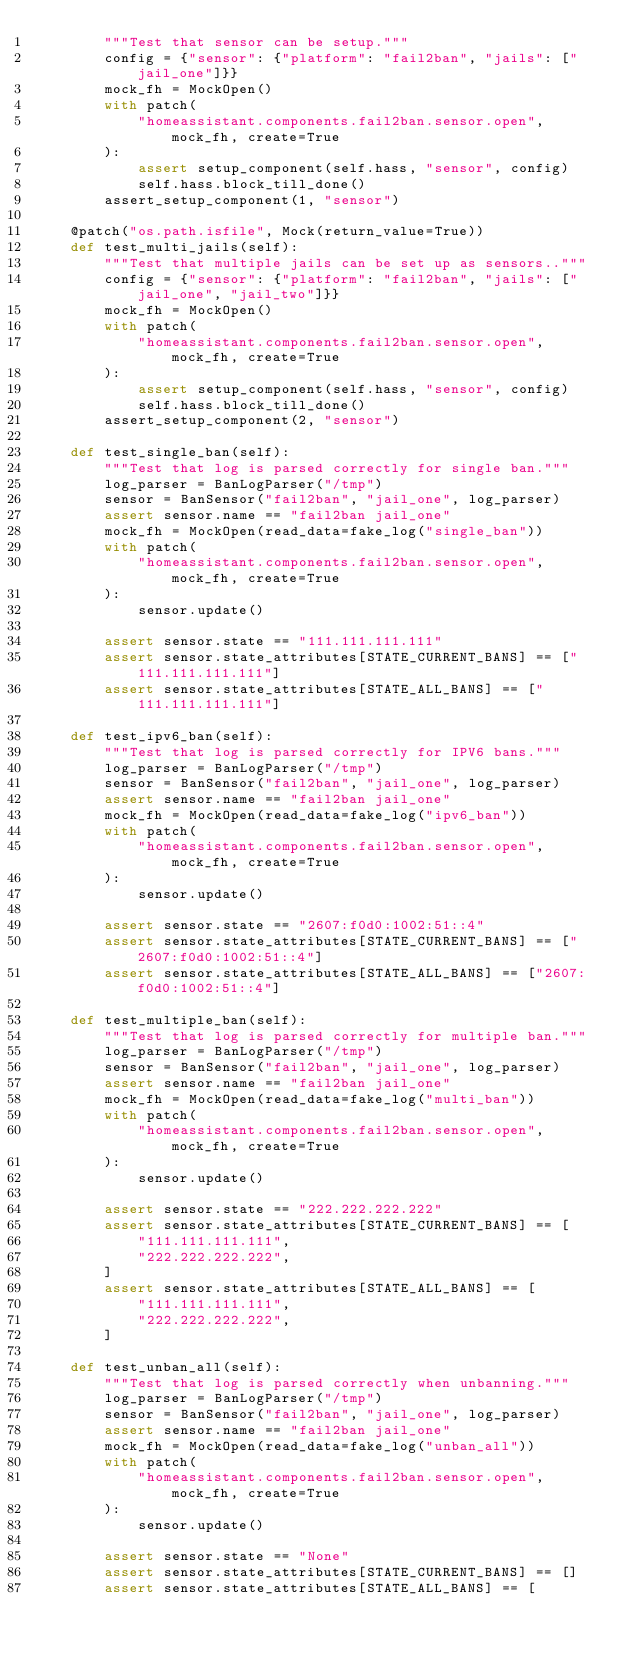Convert code to text. <code><loc_0><loc_0><loc_500><loc_500><_Python_>        """Test that sensor can be setup."""
        config = {"sensor": {"platform": "fail2ban", "jails": ["jail_one"]}}
        mock_fh = MockOpen()
        with patch(
            "homeassistant.components.fail2ban.sensor.open", mock_fh, create=True
        ):
            assert setup_component(self.hass, "sensor", config)
            self.hass.block_till_done()
        assert_setup_component(1, "sensor")

    @patch("os.path.isfile", Mock(return_value=True))
    def test_multi_jails(self):
        """Test that multiple jails can be set up as sensors.."""
        config = {"sensor": {"platform": "fail2ban", "jails": ["jail_one", "jail_two"]}}
        mock_fh = MockOpen()
        with patch(
            "homeassistant.components.fail2ban.sensor.open", mock_fh, create=True
        ):
            assert setup_component(self.hass, "sensor", config)
            self.hass.block_till_done()
        assert_setup_component(2, "sensor")

    def test_single_ban(self):
        """Test that log is parsed correctly for single ban."""
        log_parser = BanLogParser("/tmp")
        sensor = BanSensor("fail2ban", "jail_one", log_parser)
        assert sensor.name == "fail2ban jail_one"
        mock_fh = MockOpen(read_data=fake_log("single_ban"))
        with patch(
            "homeassistant.components.fail2ban.sensor.open", mock_fh, create=True
        ):
            sensor.update()

        assert sensor.state == "111.111.111.111"
        assert sensor.state_attributes[STATE_CURRENT_BANS] == ["111.111.111.111"]
        assert sensor.state_attributes[STATE_ALL_BANS] == ["111.111.111.111"]

    def test_ipv6_ban(self):
        """Test that log is parsed correctly for IPV6 bans."""
        log_parser = BanLogParser("/tmp")
        sensor = BanSensor("fail2ban", "jail_one", log_parser)
        assert sensor.name == "fail2ban jail_one"
        mock_fh = MockOpen(read_data=fake_log("ipv6_ban"))
        with patch(
            "homeassistant.components.fail2ban.sensor.open", mock_fh, create=True
        ):
            sensor.update()

        assert sensor.state == "2607:f0d0:1002:51::4"
        assert sensor.state_attributes[STATE_CURRENT_BANS] == ["2607:f0d0:1002:51::4"]
        assert sensor.state_attributes[STATE_ALL_BANS] == ["2607:f0d0:1002:51::4"]

    def test_multiple_ban(self):
        """Test that log is parsed correctly for multiple ban."""
        log_parser = BanLogParser("/tmp")
        sensor = BanSensor("fail2ban", "jail_one", log_parser)
        assert sensor.name == "fail2ban jail_one"
        mock_fh = MockOpen(read_data=fake_log("multi_ban"))
        with patch(
            "homeassistant.components.fail2ban.sensor.open", mock_fh, create=True
        ):
            sensor.update()

        assert sensor.state == "222.222.222.222"
        assert sensor.state_attributes[STATE_CURRENT_BANS] == [
            "111.111.111.111",
            "222.222.222.222",
        ]
        assert sensor.state_attributes[STATE_ALL_BANS] == [
            "111.111.111.111",
            "222.222.222.222",
        ]

    def test_unban_all(self):
        """Test that log is parsed correctly when unbanning."""
        log_parser = BanLogParser("/tmp")
        sensor = BanSensor("fail2ban", "jail_one", log_parser)
        assert sensor.name == "fail2ban jail_one"
        mock_fh = MockOpen(read_data=fake_log("unban_all"))
        with patch(
            "homeassistant.components.fail2ban.sensor.open", mock_fh, create=True
        ):
            sensor.update()

        assert sensor.state == "None"
        assert sensor.state_attributes[STATE_CURRENT_BANS] == []
        assert sensor.state_attributes[STATE_ALL_BANS] == [</code> 